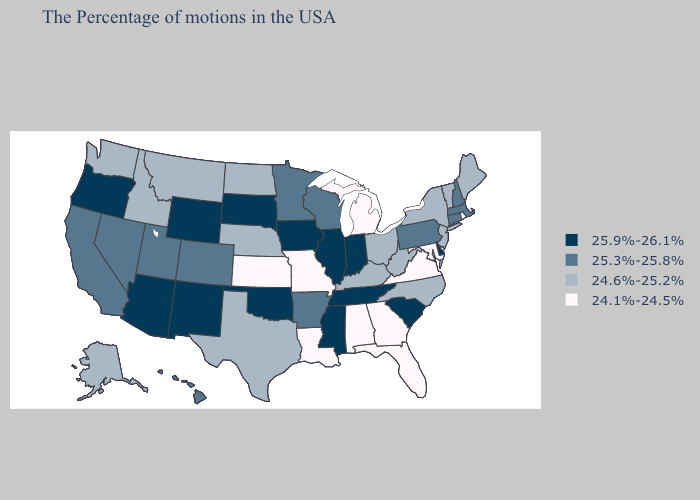What is the lowest value in the West?
Short answer required. 24.6%-25.2%. Does Delaware have the lowest value in the USA?
Answer briefly. No. Name the states that have a value in the range 24.1%-24.5%?
Short answer required. Rhode Island, Maryland, Virginia, Florida, Georgia, Michigan, Alabama, Louisiana, Missouri, Kansas. Does Idaho have a higher value than New Mexico?
Concise answer only. No. What is the value of Missouri?
Concise answer only. 24.1%-24.5%. What is the value of Maryland?
Quick response, please. 24.1%-24.5%. Name the states that have a value in the range 24.1%-24.5%?
Keep it brief. Rhode Island, Maryland, Virginia, Florida, Georgia, Michigan, Alabama, Louisiana, Missouri, Kansas. Which states hav the highest value in the Northeast?
Quick response, please. Massachusetts, New Hampshire, Connecticut, Pennsylvania. Among the states that border West Virginia , does Maryland have the lowest value?
Write a very short answer. Yes. Does New Mexico have the lowest value in the West?
Be succinct. No. Does Alabama have the lowest value in the South?
Short answer required. Yes. What is the value of Oregon?
Keep it brief. 25.9%-26.1%. Among the states that border Vermont , which have the lowest value?
Be succinct. New York. What is the value of Nevada?
Short answer required. 25.3%-25.8%. Does Iowa have the same value as Wyoming?
Answer briefly. Yes. 